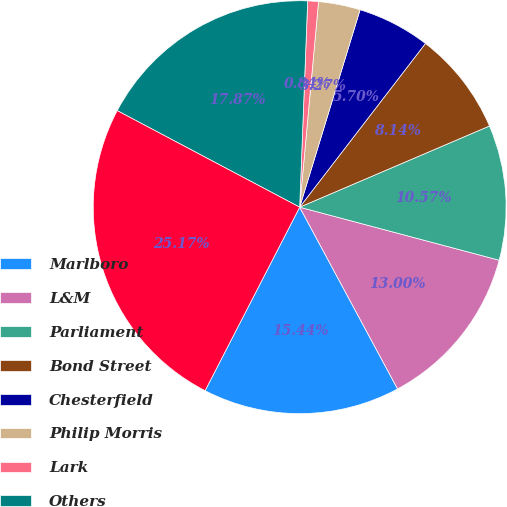<chart> <loc_0><loc_0><loc_500><loc_500><pie_chart><fcel>Marlboro<fcel>L&M<fcel>Parliament<fcel>Bond Street<fcel>Chesterfield<fcel>Philip Morris<fcel>Lark<fcel>Others<fcel>Total PMI<nl><fcel>15.44%<fcel>13.0%<fcel>10.57%<fcel>8.14%<fcel>5.7%<fcel>3.27%<fcel>0.84%<fcel>17.87%<fcel>25.17%<nl></chart> 